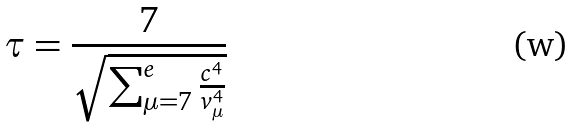Convert formula to latex. <formula><loc_0><loc_0><loc_500><loc_500>\tau = \frac { 7 } { \sqrt { \sum _ { \mu = 7 } ^ { e } \frac { c ^ { 4 } } { v _ { \mu } ^ { 4 } } } }</formula> 